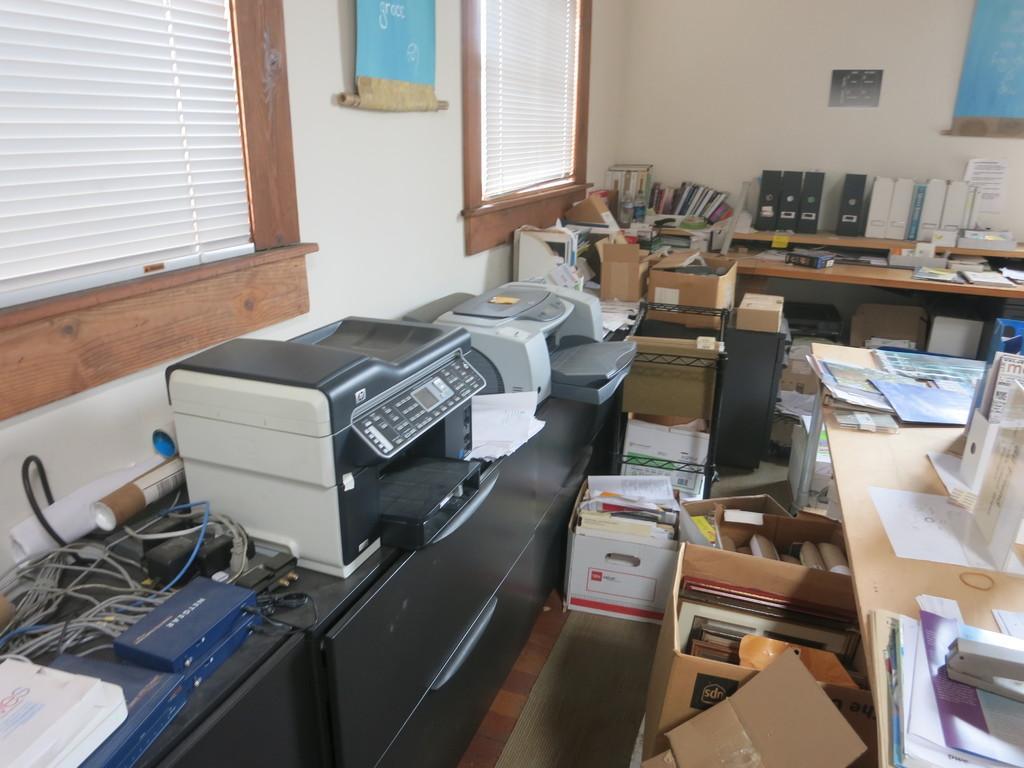Describe this image in one or two sentences. In this image, we can see cables, papers, books, a printer, boxes, tables and there is a scanner and some other objects are present. In the background, there are windows and we can see banners and a poster on the wall. 